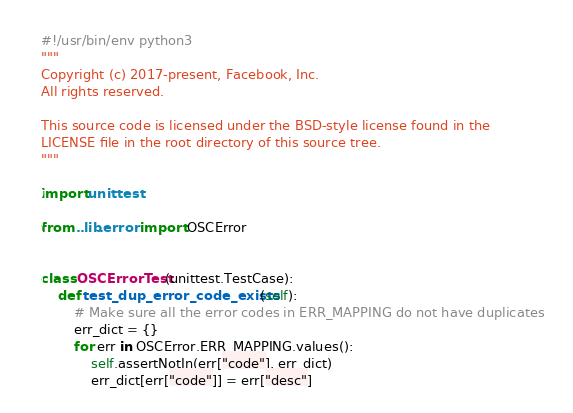<code> <loc_0><loc_0><loc_500><loc_500><_Python_>#!/usr/bin/env python3
"""
Copyright (c) 2017-present, Facebook, Inc.
All rights reserved.

This source code is licensed under the BSD-style license found in the
LICENSE file in the root directory of this source tree.
"""

import unittest

from ..lib.error import OSCError


class OSCErrorTest(unittest.TestCase):
    def test_dup_error_code_exists(self):
        # Make sure all the error codes in ERR_MAPPING do not have duplicates
        err_dict = {}
        for err in OSCError.ERR_MAPPING.values():
            self.assertNotIn(err["code"], err_dict)
            err_dict[err["code"]] = err["desc"]
</code> 